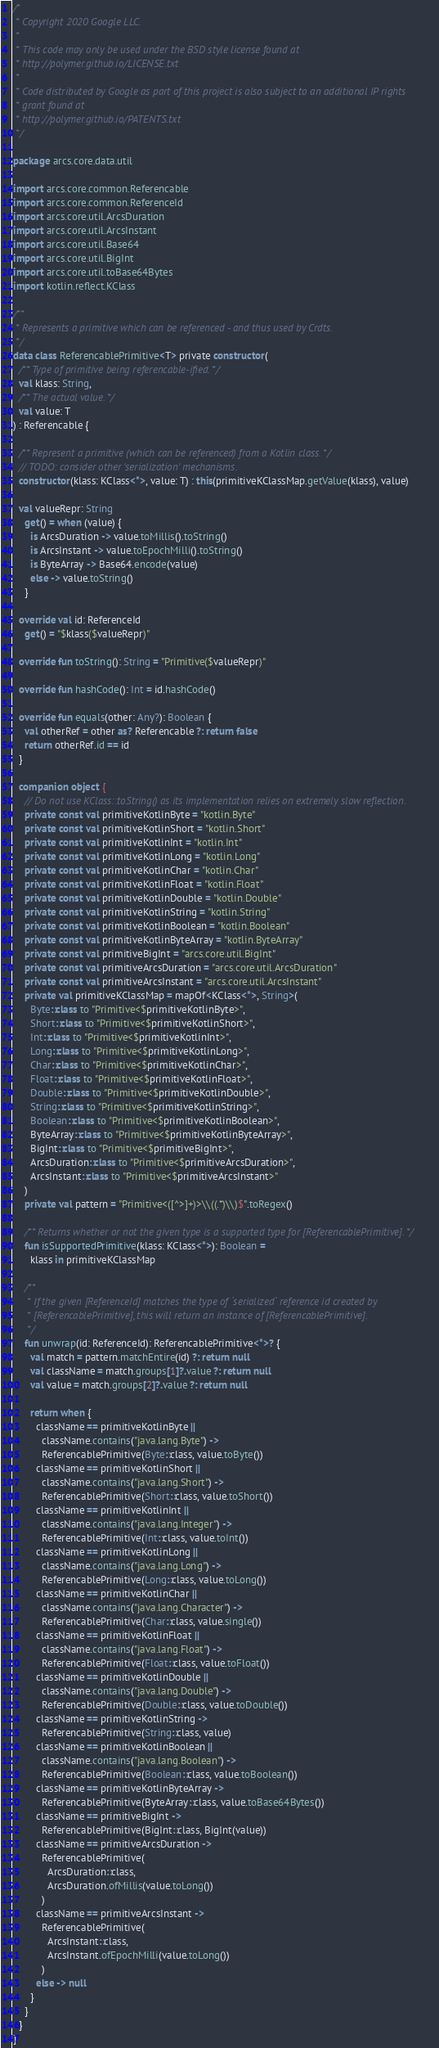<code> <loc_0><loc_0><loc_500><loc_500><_Kotlin_>/*
 * Copyright 2020 Google LLC.
 *
 * This code may only be used under the BSD style license found at
 * http://polymer.github.io/LICENSE.txt
 *
 * Code distributed by Google as part of this project is also subject to an additional IP rights
 * grant found at
 * http://polymer.github.io/PATENTS.txt
 */

package arcs.core.data.util

import arcs.core.common.Referencable
import arcs.core.common.ReferenceId
import arcs.core.util.ArcsDuration
import arcs.core.util.ArcsInstant
import arcs.core.util.Base64
import arcs.core.util.BigInt
import arcs.core.util.toBase64Bytes
import kotlin.reflect.KClass

/**
 * Represents a primitive which can be referenced - and thus used by Crdts.
 */
data class ReferencablePrimitive<T> private constructor(
  /** Type of primitive being referencable-ified. */
  val klass: String,
  /** The actual value. */
  val value: T
) : Referencable {

  /** Represent a primitive (which can be referenced) from a Kotlin class. */
  // TODO: consider other 'serialization' mechanisms.
  constructor(klass: KClass<*>, value: T) : this(primitiveKClassMap.getValue(klass), value)

  val valueRepr: String
    get() = when (value) {
      is ArcsDuration -> value.toMillis().toString()
      is ArcsInstant -> value.toEpochMilli().toString()
      is ByteArray -> Base64.encode(value)
      else -> value.toString()
    }

  override val id: ReferenceId
    get() = "$klass($valueRepr)"

  override fun toString(): String = "Primitive($valueRepr)"

  override fun hashCode(): Int = id.hashCode()

  override fun equals(other: Any?): Boolean {
    val otherRef = other as? Referencable ?: return false
    return otherRef.id == id
  }

  companion object {
    // Do not use KClass::toString() as its implementation relies on extremely slow reflection.
    private const val primitiveKotlinByte = "kotlin.Byte"
    private const val primitiveKotlinShort = "kotlin.Short"
    private const val primitiveKotlinInt = "kotlin.Int"
    private const val primitiveKotlinLong = "kotlin.Long"
    private const val primitiveKotlinChar = "kotlin.Char"
    private const val primitiveKotlinFloat = "kotlin.Float"
    private const val primitiveKotlinDouble = "kotlin.Double"
    private const val primitiveKotlinString = "kotlin.String"
    private const val primitiveKotlinBoolean = "kotlin.Boolean"
    private const val primitiveKotlinByteArray = "kotlin.ByteArray"
    private const val primitiveBigInt = "arcs.core.util.BigInt"
    private const val primitiveArcsDuration = "arcs.core.util.ArcsDuration"
    private const val primitiveArcsInstant = "arcs.core.util.ArcsInstant"
    private val primitiveKClassMap = mapOf<KClass<*>, String>(
      Byte::class to "Primitive<$primitiveKotlinByte>",
      Short::class to "Primitive<$primitiveKotlinShort>",
      Int::class to "Primitive<$primitiveKotlinInt>",
      Long::class to "Primitive<$primitiveKotlinLong>",
      Char::class to "Primitive<$primitiveKotlinChar>",
      Float::class to "Primitive<$primitiveKotlinFloat>",
      Double::class to "Primitive<$primitiveKotlinDouble>",
      String::class to "Primitive<$primitiveKotlinString>",
      Boolean::class to "Primitive<$primitiveKotlinBoolean>",
      ByteArray::class to "Primitive<$primitiveKotlinByteArray>",
      BigInt::class to "Primitive<$primitiveBigInt>",
      ArcsDuration::class to "Primitive<$primitiveArcsDuration>",
      ArcsInstant::class to "Primitive<$primitiveArcsInstant>"
    )
    private val pattern = "Primitive<([^>]+)>\\((.*)\\)$".toRegex()

    /** Returns whether or not the given type is a supported type for [ReferencablePrimitive]. */
    fun isSupportedPrimitive(klass: KClass<*>): Boolean =
      klass in primitiveKClassMap

    /**
     * If the given [ReferenceId] matches the type of `serialized` reference id created by
     * [ReferencablePrimitive], this will return an instance of [ReferencablePrimitive].
     */
    fun unwrap(id: ReferenceId): ReferencablePrimitive<*>? {
      val match = pattern.matchEntire(id) ?: return null
      val className = match.groups[1]?.value ?: return null
      val value = match.groups[2]?.value ?: return null

      return when {
        className == primitiveKotlinByte ||
          className.contains("java.lang.Byte") ->
          ReferencablePrimitive(Byte::class, value.toByte())
        className == primitiveKotlinShort ||
          className.contains("java.lang.Short") ->
          ReferencablePrimitive(Short::class, value.toShort())
        className == primitiveKotlinInt ||
          className.contains("java.lang.Integer") ->
          ReferencablePrimitive(Int::class, value.toInt())
        className == primitiveKotlinLong ||
          className.contains("java.lang.Long") ->
          ReferencablePrimitive(Long::class, value.toLong())
        className == primitiveKotlinChar ||
          className.contains("java.lang.Character") ->
          ReferencablePrimitive(Char::class, value.single())
        className == primitiveKotlinFloat ||
          className.contains("java.lang.Float") ->
          ReferencablePrimitive(Float::class, value.toFloat())
        className == primitiveKotlinDouble ||
          className.contains("java.lang.Double") ->
          ReferencablePrimitive(Double::class, value.toDouble())
        className == primitiveKotlinString ->
          ReferencablePrimitive(String::class, value)
        className == primitiveKotlinBoolean ||
          className.contains("java.lang.Boolean") ->
          ReferencablePrimitive(Boolean::class, value.toBoolean())
        className == primitiveKotlinByteArray ->
          ReferencablePrimitive(ByteArray::class, value.toBase64Bytes())
        className == primitiveBigInt ->
          ReferencablePrimitive(BigInt::class, BigInt(value))
        className == primitiveArcsDuration ->
          ReferencablePrimitive(
            ArcsDuration::class,
            ArcsDuration.ofMillis(value.toLong())
          )
        className == primitiveArcsInstant ->
          ReferencablePrimitive(
            ArcsInstant::class,
            ArcsInstant.ofEpochMilli(value.toLong())
          )
        else -> null
      }
    }
  }
}
</code> 